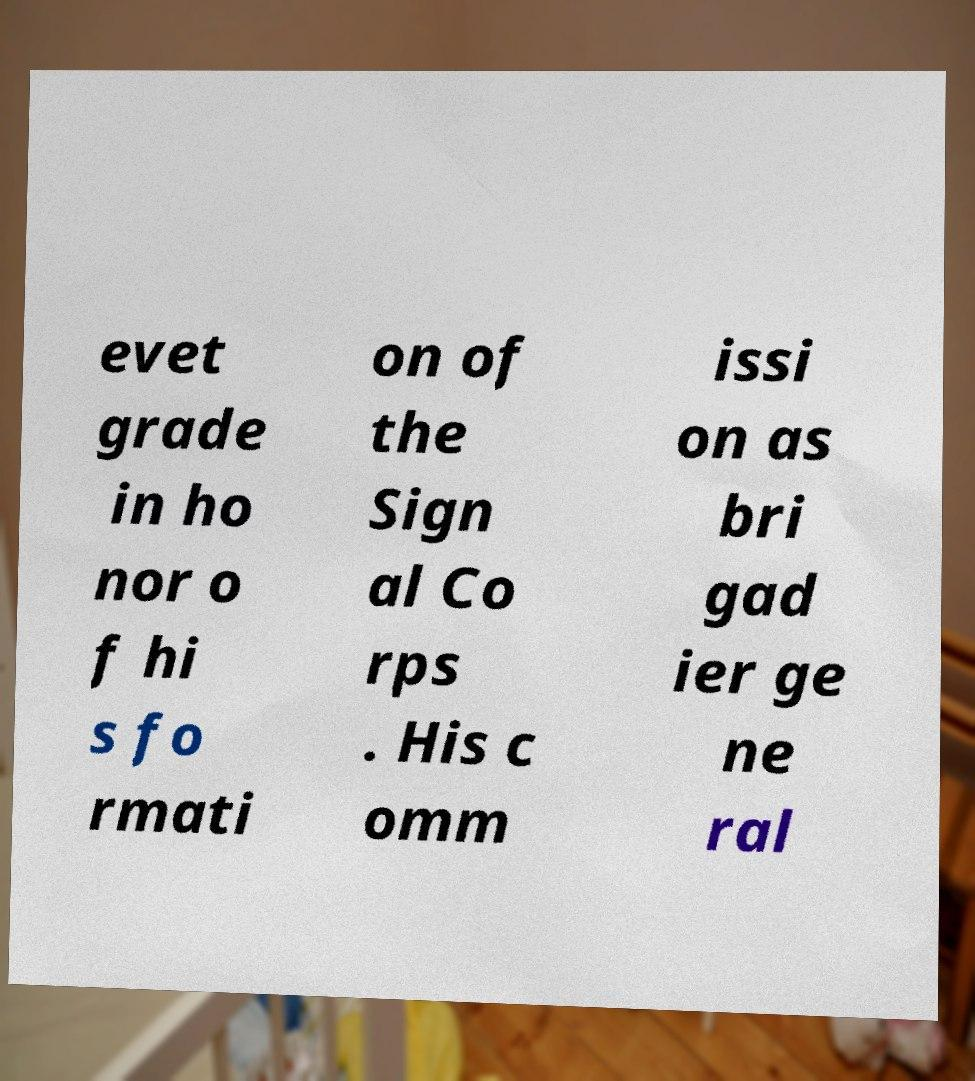There's text embedded in this image that I need extracted. Can you transcribe it verbatim? evet grade in ho nor o f hi s fo rmati on of the Sign al Co rps . His c omm issi on as bri gad ier ge ne ral 